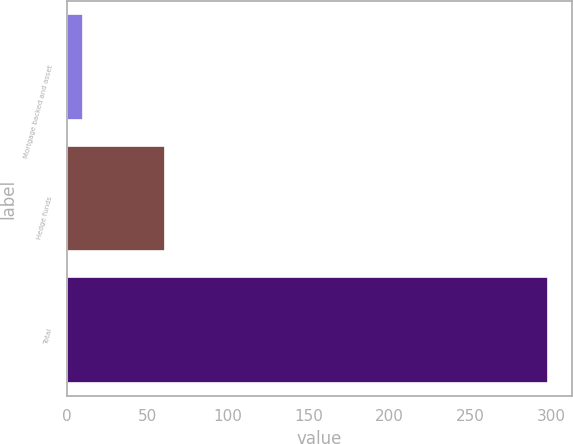Convert chart. <chart><loc_0><loc_0><loc_500><loc_500><bar_chart><fcel>Mortgage backed and asset<fcel>Hedge funds<fcel>Total<nl><fcel>10<fcel>61<fcel>298<nl></chart> 